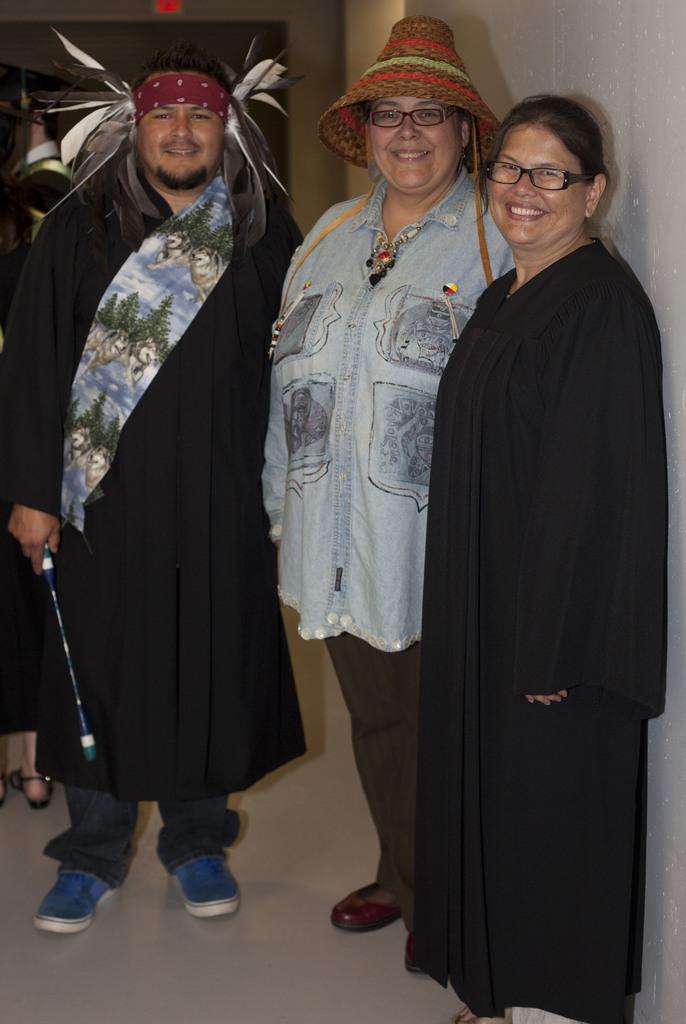Can you describe this image briefly? In this image we can see few persons. On the left side, we can see a person holding an object. Behind the persons we can see the wall. 